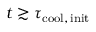Convert formula to latex. <formula><loc_0><loc_0><loc_500><loc_500>t \gtrsim \tau _ { c o o l , \, i n i t }</formula> 